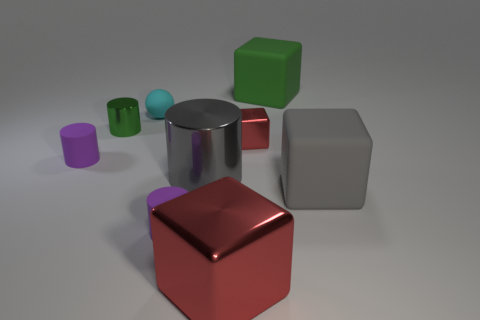Subtract all green blocks. How many blocks are left? 3 Subtract all gray cubes. How many cubes are left? 3 Subtract all balls. How many objects are left? 8 Add 2 tiny green cylinders. How many tiny green cylinders exist? 3 Add 1 big metallic objects. How many objects exist? 10 Subtract 0 gray balls. How many objects are left? 9 Subtract 1 blocks. How many blocks are left? 3 Subtract all green balls. Subtract all blue cylinders. How many balls are left? 1 Subtract all blue cubes. How many purple cylinders are left? 2 Subtract all green cylinders. Subtract all small shiny things. How many objects are left? 6 